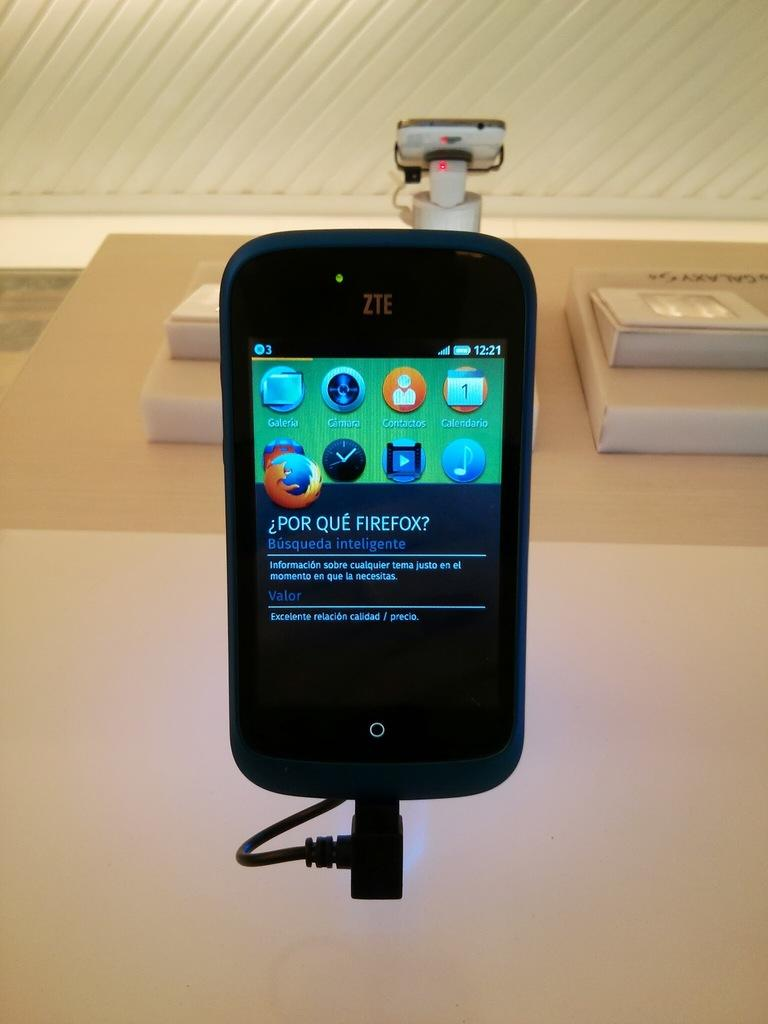<image>
Relay a brief, clear account of the picture shown. a cellphone showing in the screen why use firefox as the main browser 